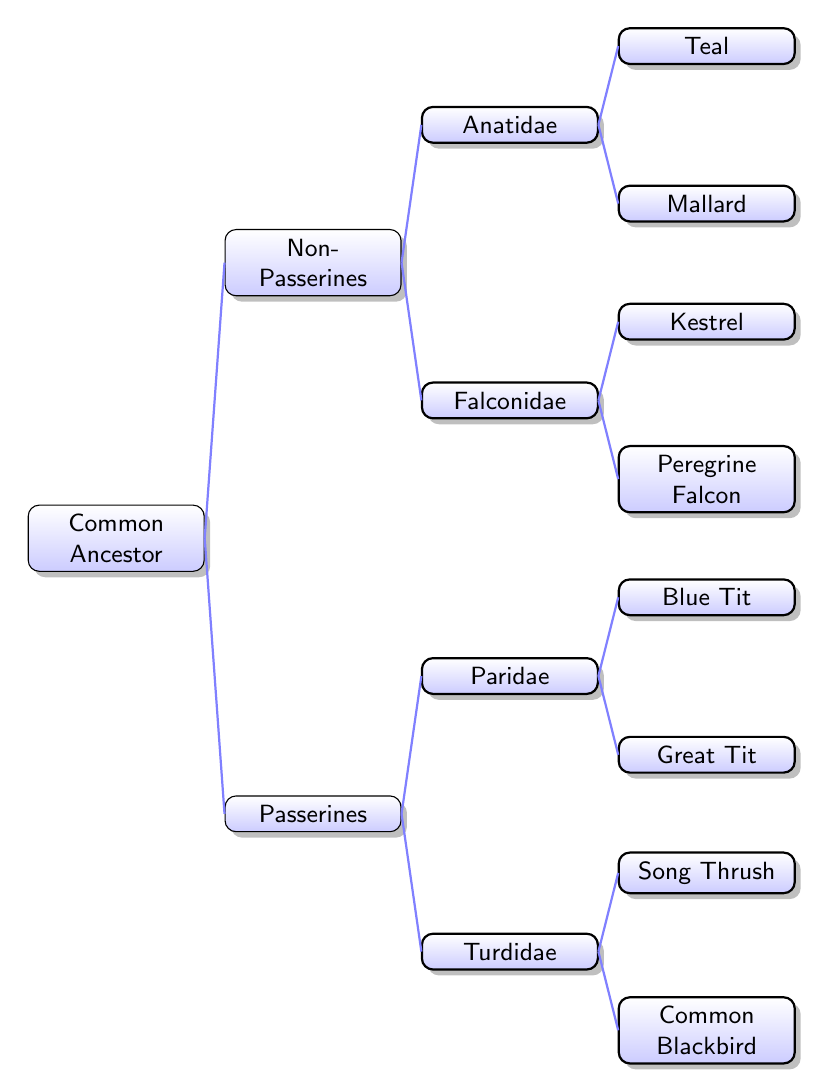What is the common ancestor of the birds in this diagram? The top node labeled "Common Ancestor" represents the point from which all species in the diagram have evolved.
Answer: Common Ancestor How many families are represented in the Passerines category? Under the Passerines category, there are two families listed: Turdidae and Paridae. Therefore, the count is 2.
Answer: 2 Which bird is a member of the Turdidae family? The children of the Turdidae family are the Common Blackbird and the Song Thrush. Both are members of this family, but only one is needed for this answer.
Answer: Common Blackbird How many species are classified under Non-Passerines? In the Non-Passerines category, the diagram shows two families (Falconidae and Anatidae), each with two species (Peregrine Falcon, Kestrel in Falconidae and Mallard, Teal in Anatidae), making a total of 4 species.
Answer: 4 What is the relationship between the Great Tit and Blue Tit? The Great Tit and Blue Tit are both children of the Paridae family, which means they share a common family lineage under Passerines.
Answer: Siblings Which bird is located at the second level of the tree from the common ancestor? At the second level, we see two main branches: Passerines and Non-Passerines. Each category has its own subjects from this level, specifically naming the families such as Turdidae and Falconidae.
Answer: Passerines, Non-Passerines Which bird belongs to the Anatidae family? The Anatidae family includes the Mallard and Teal. This question requires identifying a bird under that family.
Answer: Mallard How many edges connect the Common Ancestor to the next level? From the Common Ancestor, there are two edges that connect it to the first level of the tree: one to Passerines and one to Non-Passerines.
Answer: 2 Which genus does the Kestrel belong to? The Kestrel is classified under the Falconidae family, indicating that it belongs to that genus which is a family of birds of prey.
Answer: Falconidae 